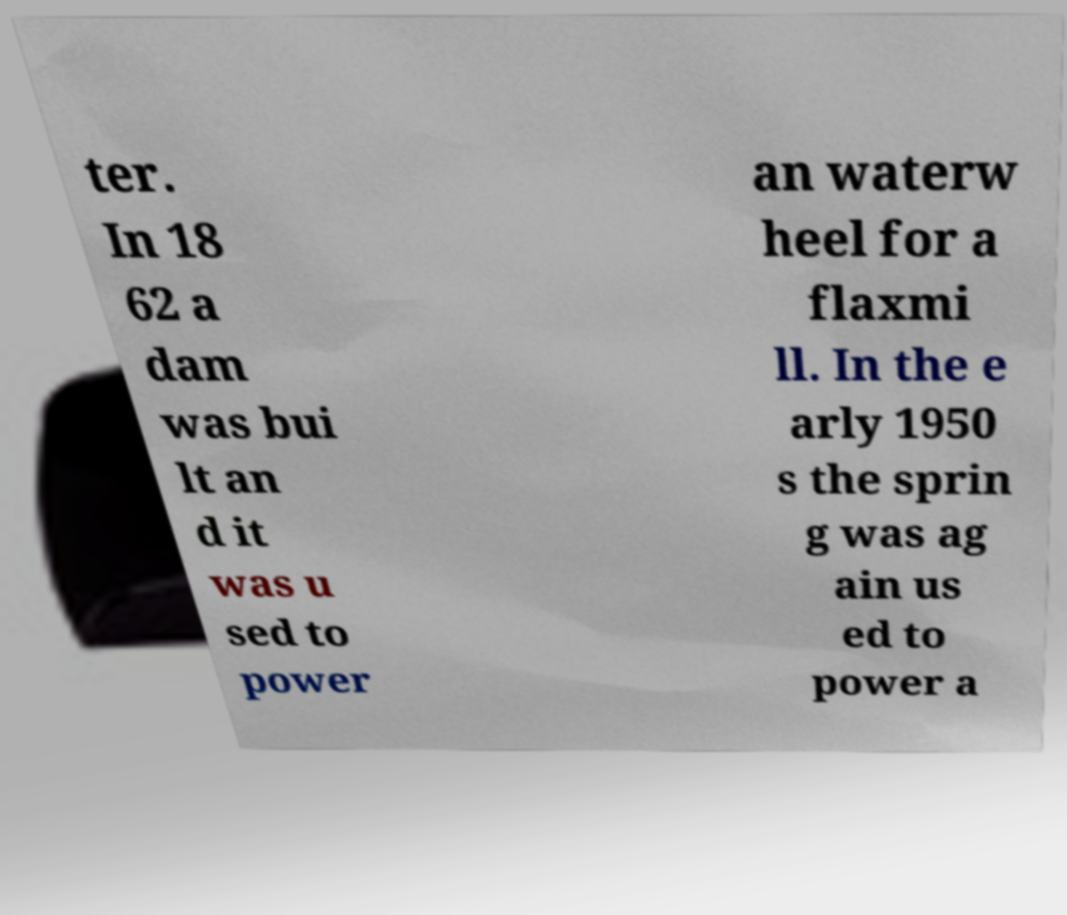I need the written content from this picture converted into text. Can you do that? ter. In 18 62 a dam was bui lt an d it was u sed to power an waterw heel for a flaxmi ll. In the e arly 1950 s the sprin g was ag ain us ed to power a 